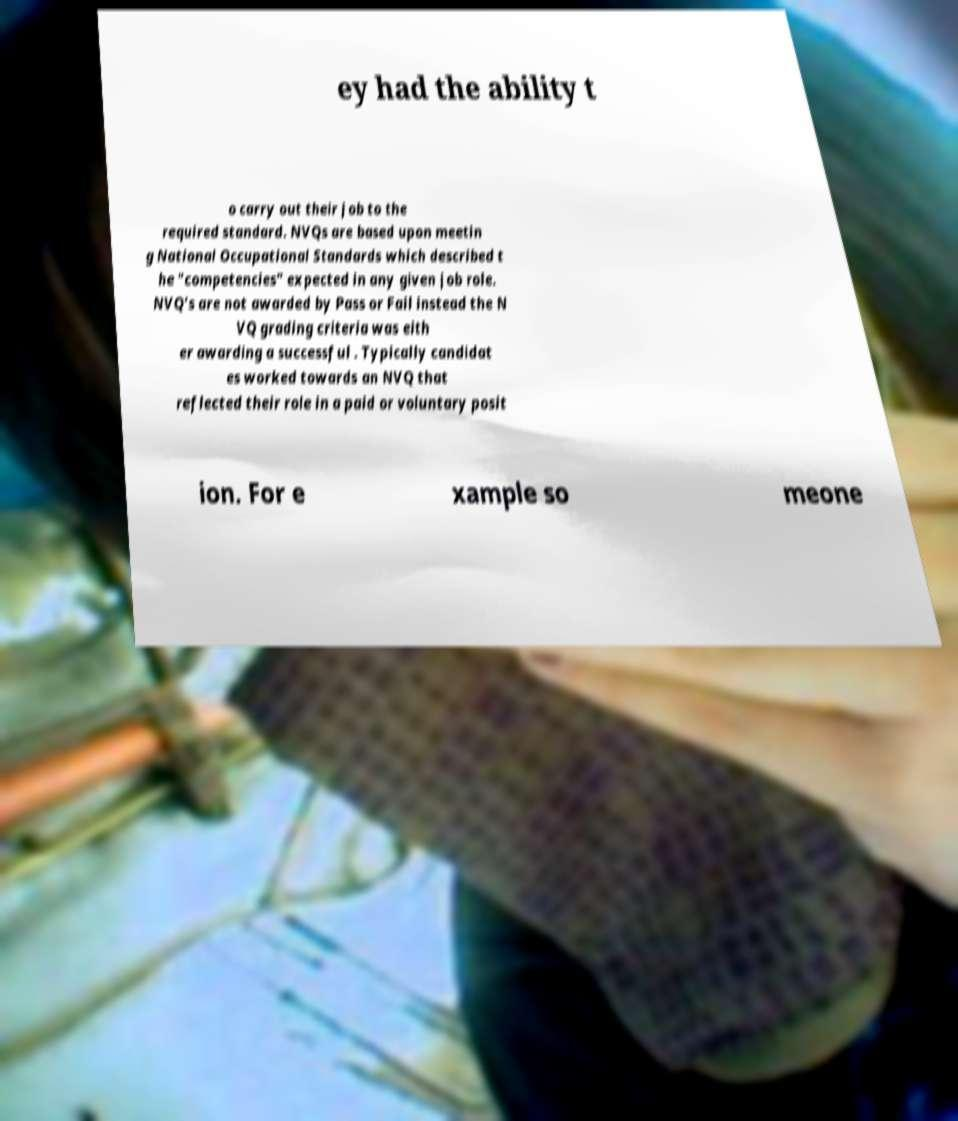What messages or text are displayed in this image? I need them in a readable, typed format. ey had the ability t o carry out their job to the required standard. NVQs are based upon meetin g National Occupational Standards which described t he "competencies" expected in any given job role. NVQ's are not awarded by Pass or Fail instead the N VQ grading criteria was eith er awarding a successful . Typically candidat es worked towards an NVQ that reflected their role in a paid or voluntary posit ion. For e xample so meone 